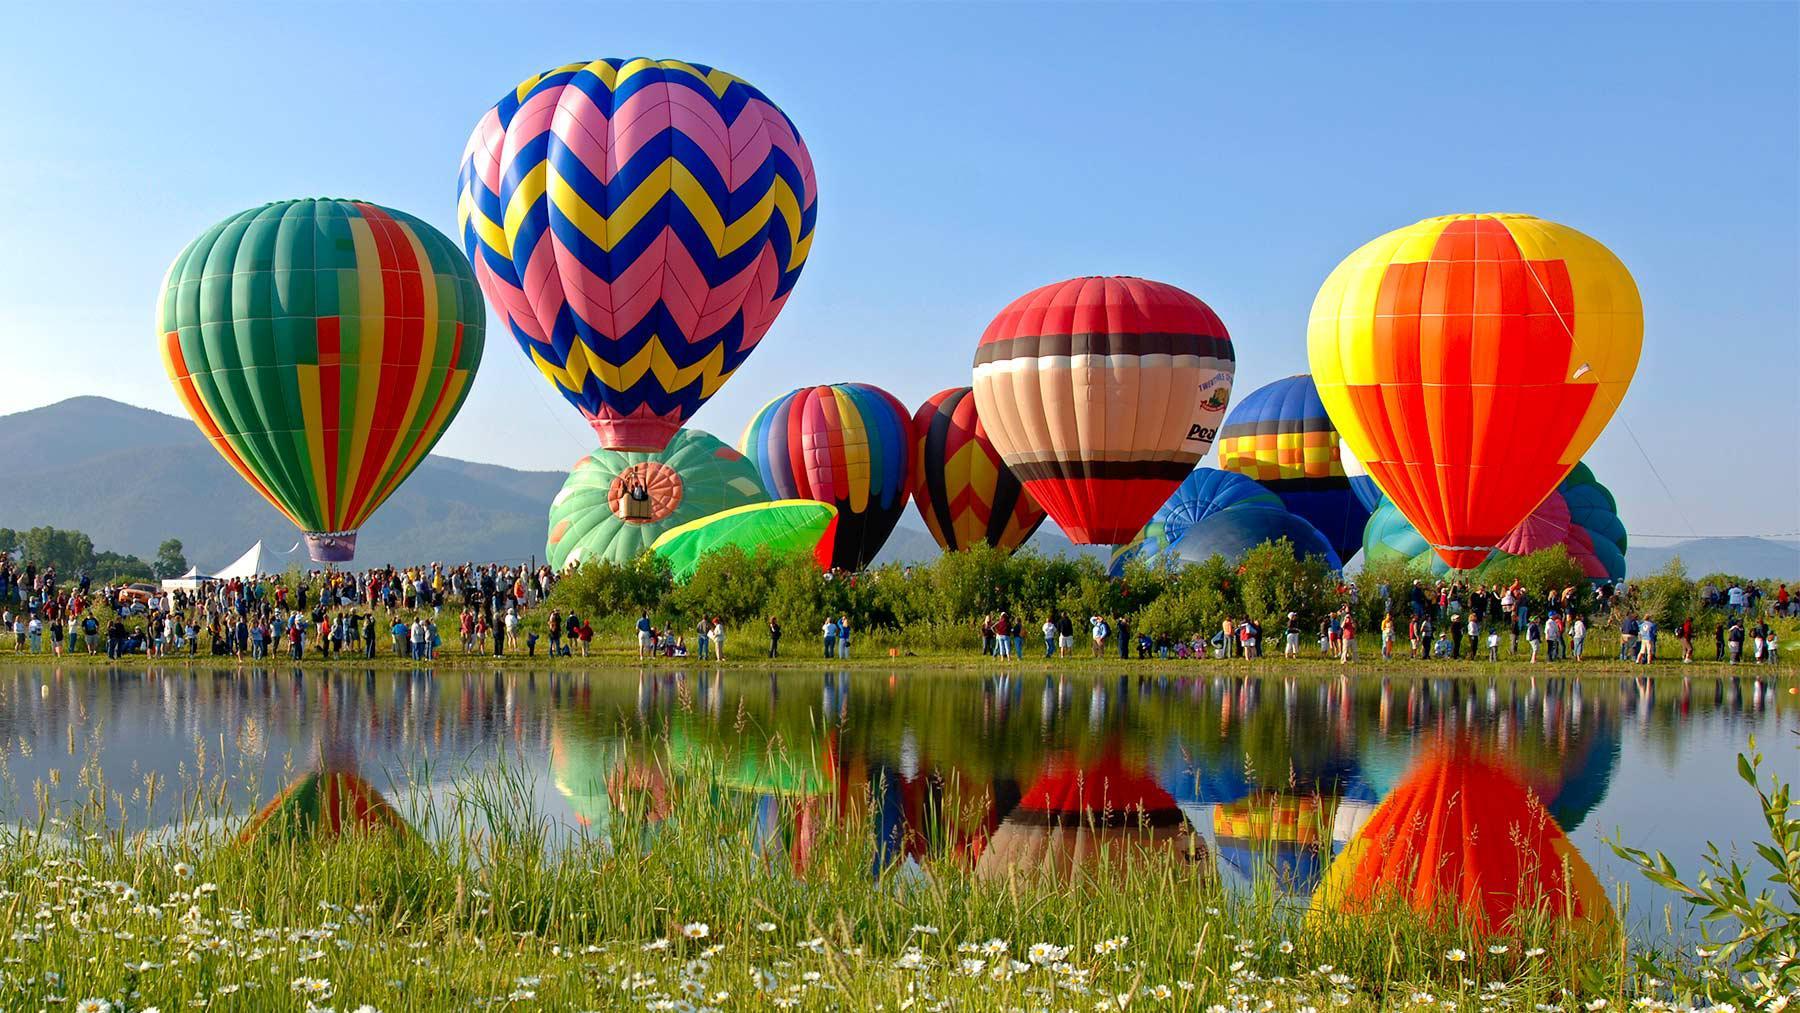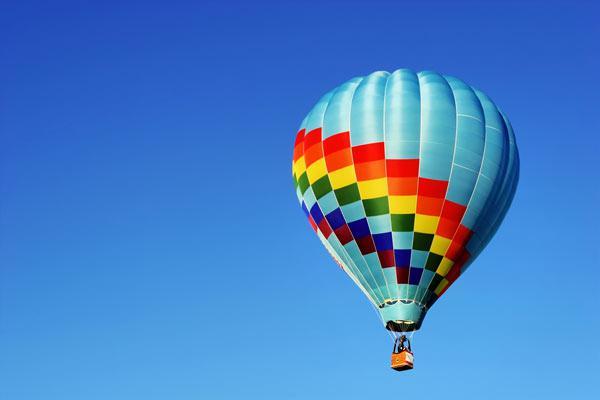The first image is the image on the left, the second image is the image on the right. Considering the images on both sides, is "there are exactly seven balloons in the image on the right" valid? Answer yes or no. No. The first image is the image on the left, the second image is the image on the right. For the images shown, is this caption "An image shows just one multi-colored balloon against a cloudless sky." true? Answer yes or no. Yes. 